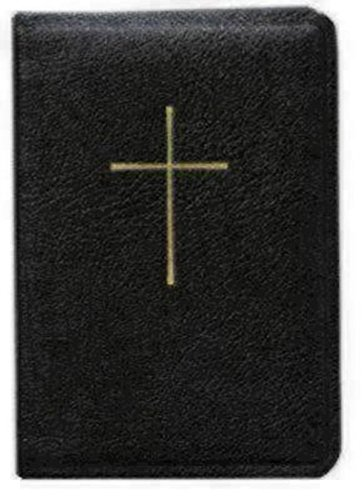Can you tell me what material the cover of this book might be made of? The cover appears to have a leather-like texture, which is common for bibles and prayer books, giving them a durable and classic appearance. Is there anything else distinctive about this book’s appearance? Besides the leather-like cover, the gold embossed cross on the cover stands out as a significant religious symbol, indicating the holy content within the book. 